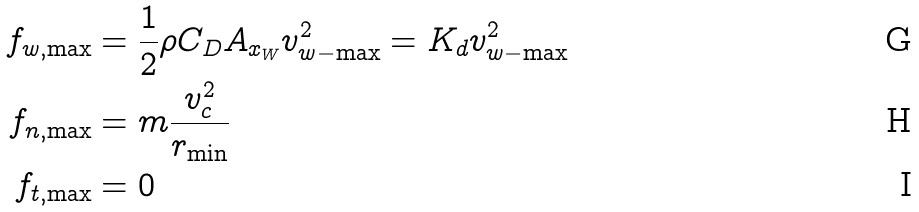<formula> <loc_0><loc_0><loc_500><loc_500>f _ { w , \max } & = \frac { 1 } { 2 } \rho C _ { D } A _ { x _ { W } } v _ { w - \max } ^ { 2 } = K _ { d } v _ { w - \max } ^ { 2 } \\ f _ { n , \max } & = m \frac { v _ { c } ^ { 2 } } { r _ { \min } } \\ f _ { t , \max } & = 0</formula> 